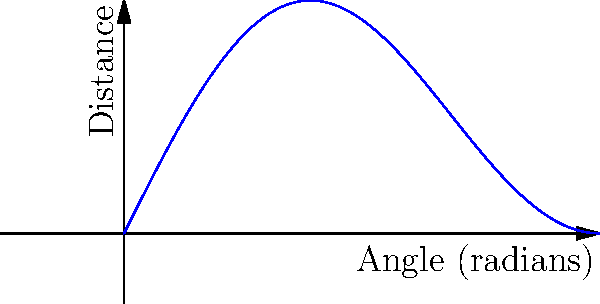As a devoted hockey fan who grew up watching William Flynn's legendary slap shots, you're analyzing the optimal angle for maximum shot distance. The distance $D$ of a slap shot as a function of the angle $\theta$ (in radians) is given by $D(\theta) = \sin(2\theta)\cos(\theta)$, where $0 \leq \theta \leq \frac{\pi}{2}$. Find the angle that maximizes the shot distance. To find the maximum distance, we need to follow these steps:

1) First, we need to find the derivative of $D(\theta)$:
   $D'(\theta) = \frac{d}{d\theta}[\sin(2\theta)\cos(\theta)]$
   $= 2\cos(2\theta)\cos(\theta) + \sin(2\theta)(-\sin(\theta))$
   $= 2\cos(2\theta)\cos(\theta) - \sin(2\theta)\sin(\theta)$

2) To find the maximum, we set $D'(\theta) = 0$:
   $2\cos(2\theta)\cos(\theta) - \sin(2\theta)\sin(\theta) = 0$

3) Using the identity $\cos(2\theta) = \cos^2(\theta) - \sin^2(\theta)$:
   $2(\cos^2(\theta) - \sin^2(\theta))\cos(\theta) - 2\sin(\theta)\cos(\theta)\sin(\theta) = 0$
   $2\cos^3(\theta) - 2\sin^2(\theta)\cos(\theta) - 2\sin^2(\theta)\cos(\theta) = 0$
   $2\cos^3(\theta) - 4\sin^2(\theta)\cos(\theta) = 0$

4) Factor out $2\cos(\theta)$:
   $2\cos(\theta)[\cos^2(\theta) - 2\sin^2(\theta)] = 0$

5) This is satisfied when either $\cos(\theta) = 0$ or $\cos^2(\theta) - 2\sin^2(\theta) = 0$

6) $\cos(\theta) = 0$ when $\theta = \frac{\pi}{2}$, which gives a minimum (distance = 0)

7) For $\cos^2(\theta) - 2\sin^2(\theta) = 0$:
   $\cos^2(\theta) = 2\sin^2(\theta)$
   $1 - \sin^2(\theta) = 2\sin^2(\theta)$ (using $\cos^2(\theta) + \sin^2(\theta) = 1$)
   $1 = 3\sin^2(\theta)$
   $\sin^2(\theta) = \frac{1}{3}$
   $\sin(\theta) = \frac{1}{\sqrt{3}}$

8) Therefore, $\theta = \arcsin(\frac{1}{\sqrt{3}}) \approx 0.6155$ radians or about 35.26°

9) We can confirm this is a maximum by checking the second derivative is negative at this point.
Answer: $\arcsin(\frac{1}{\sqrt{3}})$ radians or approximately 35.26° 